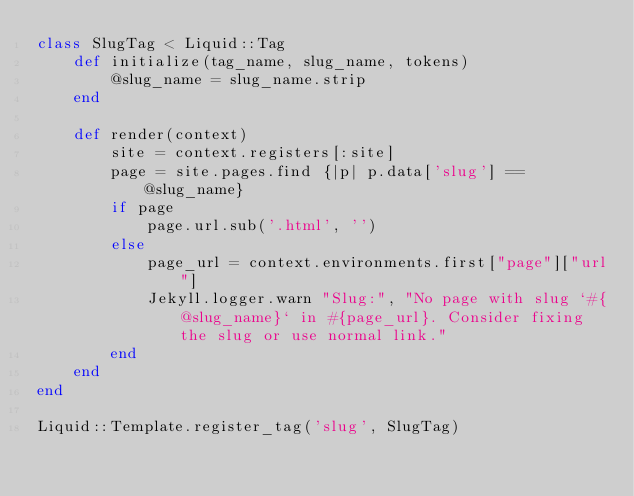Convert code to text. <code><loc_0><loc_0><loc_500><loc_500><_Ruby_>class SlugTag < Liquid::Tag
    def initialize(tag_name, slug_name, tokens)
        @slug_name = slug_name.strip
    end

    def render(context)
        site = context.registers[:site]
        page = site.pages.find {|p| p.data['slug'] == @slug_name}
        if page
            page.url.sub('.html', '')
        else
            page_url = context.environments.first["page"]["url"]
            Jekyll.logger.warn "Slug:", "No page with slug `#{@slug_name}` in #{page_url}. Consider fixing the slug or use normal link." 
        end
    end
end

Liquid::Template.register_tag('slug', SlugTag)
</code> 